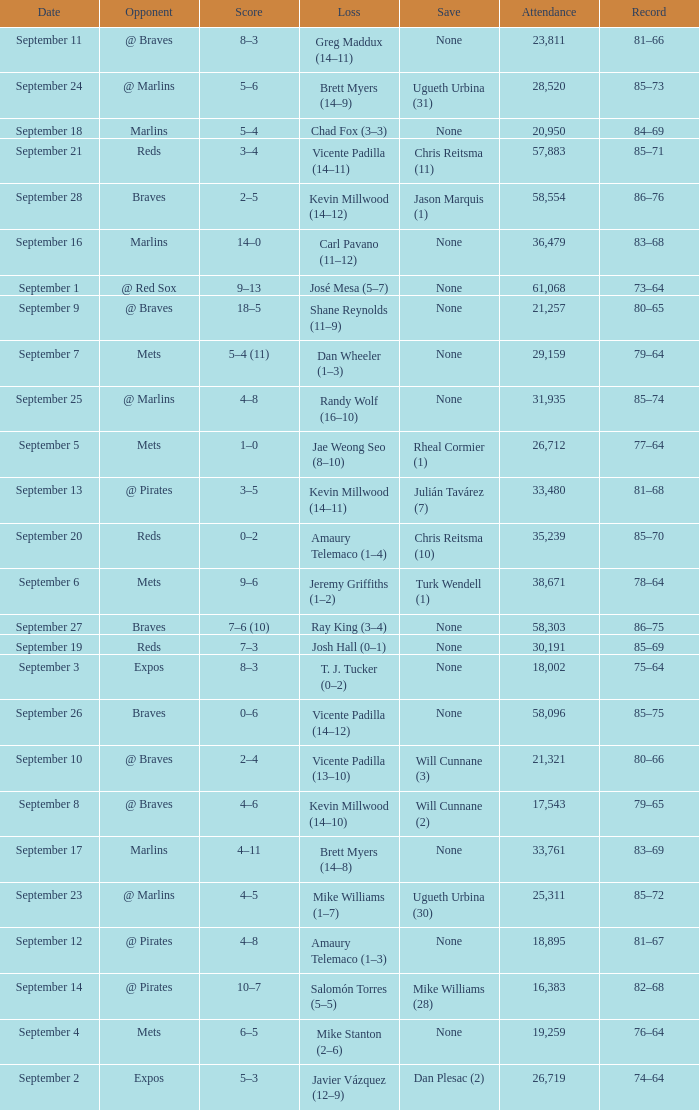What was the score of the game that had a loss of Chad Fox (3–3)? 5–4. 